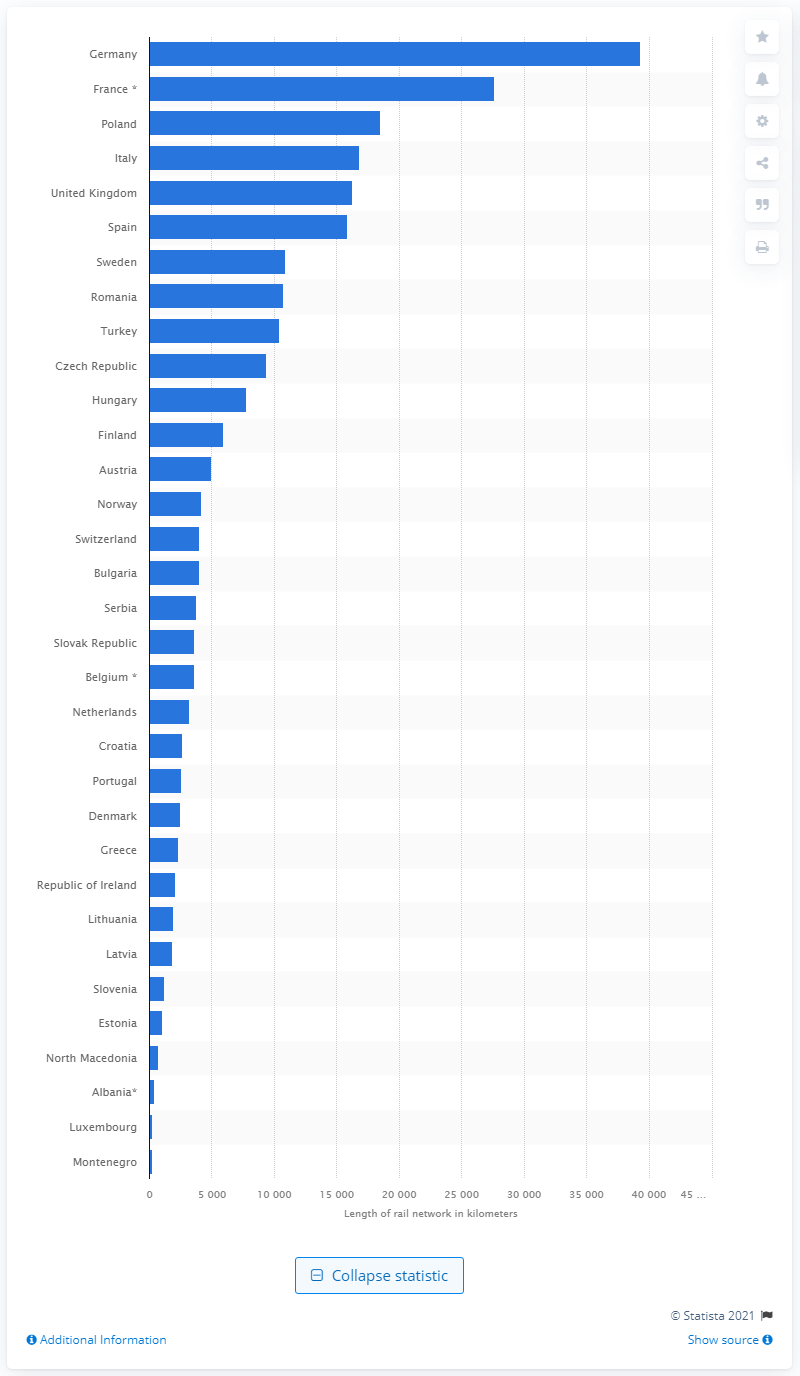Mention a couple of crucial points in this snapshot. According to available information, Poland has the longest rail network in use among all countries. 